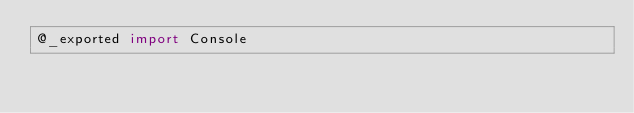<code> <loc_0><loc_0><loc_500><loc_500><_Swift_>@_exported import Console
</code> 